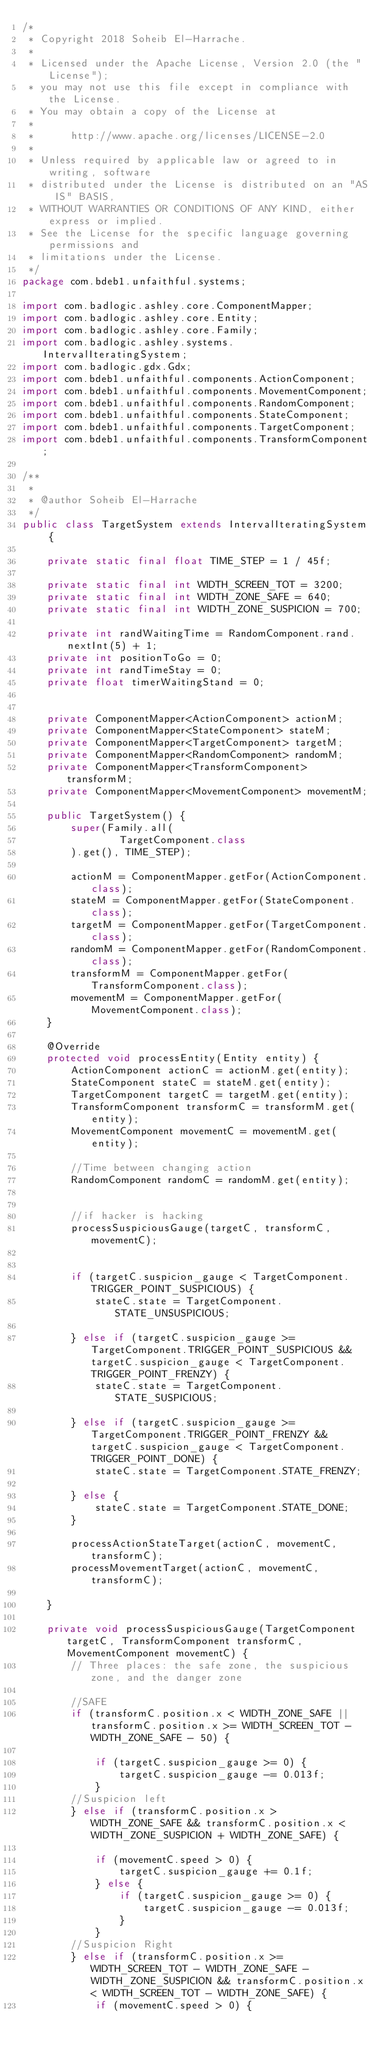Convert code to text. <code><loc_0><loc_0><loc_500><loc_500><_Java_>/*
 * Copyright 2018 Soheib El-Harrache.
 *
 * Licensed under the Apache License, Version 2.0 (the "License");
 * you may not use this file except in compliance with the License.
 * You may obtain a copy of the License at
 *
 *      http://www.apache.org/licenses/LICENSE-2.0
 *
 * Unless required by applicable law or agreed to in writing, software
 * distributed under the License is distributed on an "AS IS" BASIS,
 * WITHOUT WARRANTIES OR CONDITIONS OF ANY KIND, either express or implied.
 * See the License for the specific language governing permissions and
 * limitations under the License.
 */
package com.bdeb1.unfaithful.systems;

import com.badlogic.ashley.core.ComponentMapper;
import com.badlogic.ashley.core.Entity;
import com.badlogic.ashley.core.Family;
import com.badlogic.ashley.systems.IntervalIteratingSystem;
import com.badlogic.gdx.Gdx;
import com.bdeb1.unfaithful.components.ActionComponent;
import com.bdeb1.unfaithful.components.MovementComponent;
import com.bdeb1.unfaithful.components.RandomComponent;
import com.bdeb1.unfaithful.components.StateComponent;
import com.bdeb1.unfaithful.components.TargetComponent;
import com.bdeb1.unfaithful.components.TransformComponent;

/**
 *
 * @author Soheib El-Harrache
 */
public class TargetSystem extends IntervalIteratingSystem {

    private static final float TIME_STEP = 1 / 45f;

    private static final int WIDTH_SCREEN_TOT = 3200;
    private static final int WIDTH_ZONE_SAFE = 640;
    private static final int WIDTH_ZONE_SUSPICION = 700;

    private int randWaitingTime = RandomComponent.rand.nextInt(5) + 1;
    private int positionToGo = 0;
    private int randTimeStay = 0;
    private float timerWaitingStand = 0;

    
    private ComponentMapper<ActionComponent> actionM;
    private ComponentMapper<StateComponent> stateM;
    private ComponentMapper<TargetComponent> targetM;
    private ComponentMapper<RandomComponent> randomM;
    private ComponentMapper<TransformComponent> transformM;
    private ComponentMapper<MovementComponent> movementM;

    public TargetSystem() {
        super(Family.all(
                TargetComponent.class
        ).get(), TIME_STEP);

        actionM = ComponentMapper.getFor(ActionComponent.class);
        stateM = ComponentMapper.getFor(StateComponent.class);
        targetM = ComponentMapper.getFor(TargetComponent.class);
        randomM = ComponentMapper.getFor(RandomComponent.class);
        transformM = ComponentMapper.getFor(TransformComponent.class);
        movementM = ComponentMapper.getFor(MovementComponent.class);
    }

    @Override
    protected void processEntity(Entity entity) {
        ActionComponent actionC = actionM.get(entity);
        StateComponent stateC = stateM.get(entity);
        TargetComponent targetC = targetM.get(entity);
        TransformComponent transformC = transformM.get(entity);
        MovementComponent movementC = movementM.get(entity);
        
        //Time between changing action
        RandomComponent randomC = randomM.get(entity);

        
        //if hacker is hacking
        processSuspiciousGauge(targetC, transformC, movementC);
        
        
        if (targetC.suspicion_gauge < TargetComponent.TRIGGER_POINT_SUSPICIOUS) {
            stateC.state = TargetComponent.STATE_UNSUSPICIOUS;

        } else if (targetC.suspicion_gauge >= TargetComponent.TRIGGER_POINT_SUSPICIOUS && targetC.suspicion_gauge < TargetComponent.TRIGGER_POINT_FRENZY) {
            stateC.state = TargetComponent.STATE_SUSPICIOUS;

        } else if (targetC.suspicion_gauge >= TargetComponent.TRIGGER_POINT_FRENZY && targetC.suspicion_gauge < TargetComponent.TRIGGER_POINT_DONE) {
            stateC.state = TargetComponent.STATE_FRENZY;

        } else {
            stateC.state = TargetComponent.STATE_DONE;
        }
        
        processActionStateTarget(actionC, movementC, transformC);
        processMovementTarget(actionC, movementC, transformC);
        
    }
    
    private void processSuspiciousGauge(TargetComponent targetC, TransformComponent transformC, MovementComponent movementC) {
        // Three places: the safe zone, the suspicious zone, and the danger zone
        
        //SAFE
        if (transformC.position.x < WIDTH_ZONE_SAFE || transformC.position.x >= WIDTH_SCREEN_TOT - WIDTH_ZONE_SAFE - 50) {
            
            if (targetC.suspicion_gauge >= 0) {
                targetC.suspicion_gauge -= 0.013f;
            }
        //Suspicion left
        } else if (transformC.position.x > WIDTH_ZONE_SAFE && transformC.position.x < WIDTH_ZONE_SUSPICION + WIDTH_ZONE_SAFE) {
            
            if (movementC.speed > 0) {
                targetC.suspicion_gauge += 0.1f;
            } else {
                if (targetC.suspicion_gauge >= 0) {
                    targetC.suspicion_gauge -= 0.013f;
                }
            }
        //Suspicion Right
        } else if (transformC.position.x >= WIDTH_SCREEN_TOT - WIDTH_ZONE_SAFE - WIDTH_ZONE_SUSPICION && transformC.position.x < WIDTH_SCREEN_TOT - WIDTH_ZONE_SAFE) {
            if (movementC.speed > 0) {</code> 